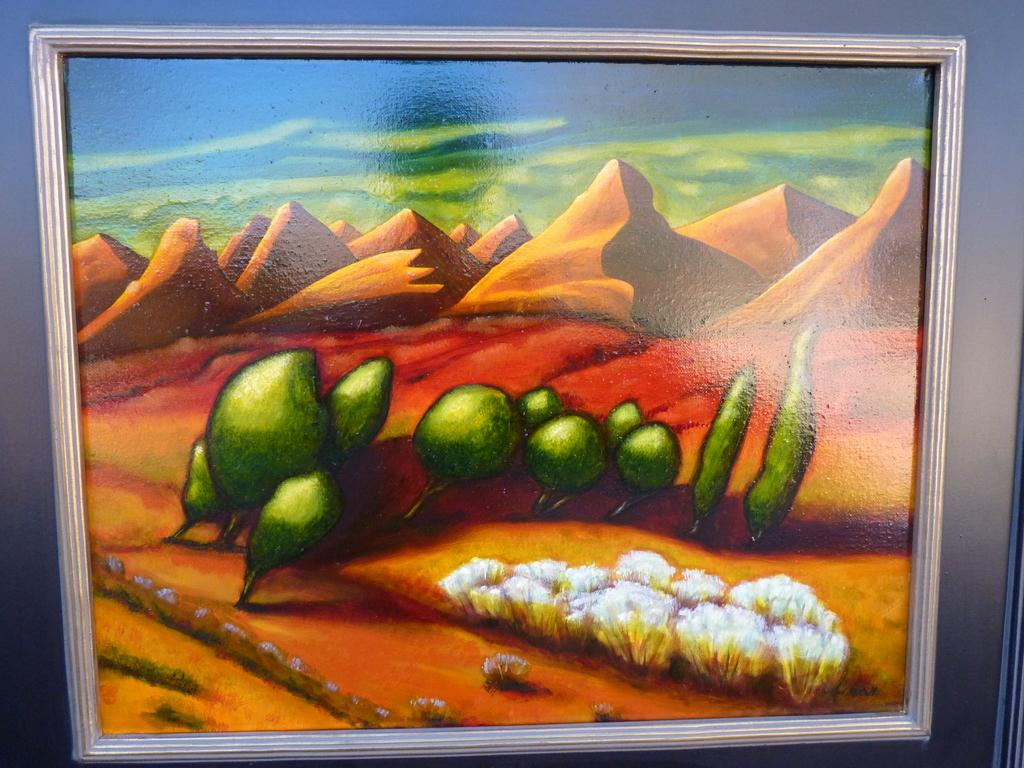What is the main object in the image? There is a photo frame in the image. What type of landscape can be seen in the image? Hills are visible in the image. Can you describe any other objects in the image besides the photo frame? There are other unspecified objects in the image. What type of brush is being used to paint the hills in the image? There is no brush or painting activity depicted in the image; it features a photo frame and hills. How many parents are visible in the image? There are no parents present in the image. 